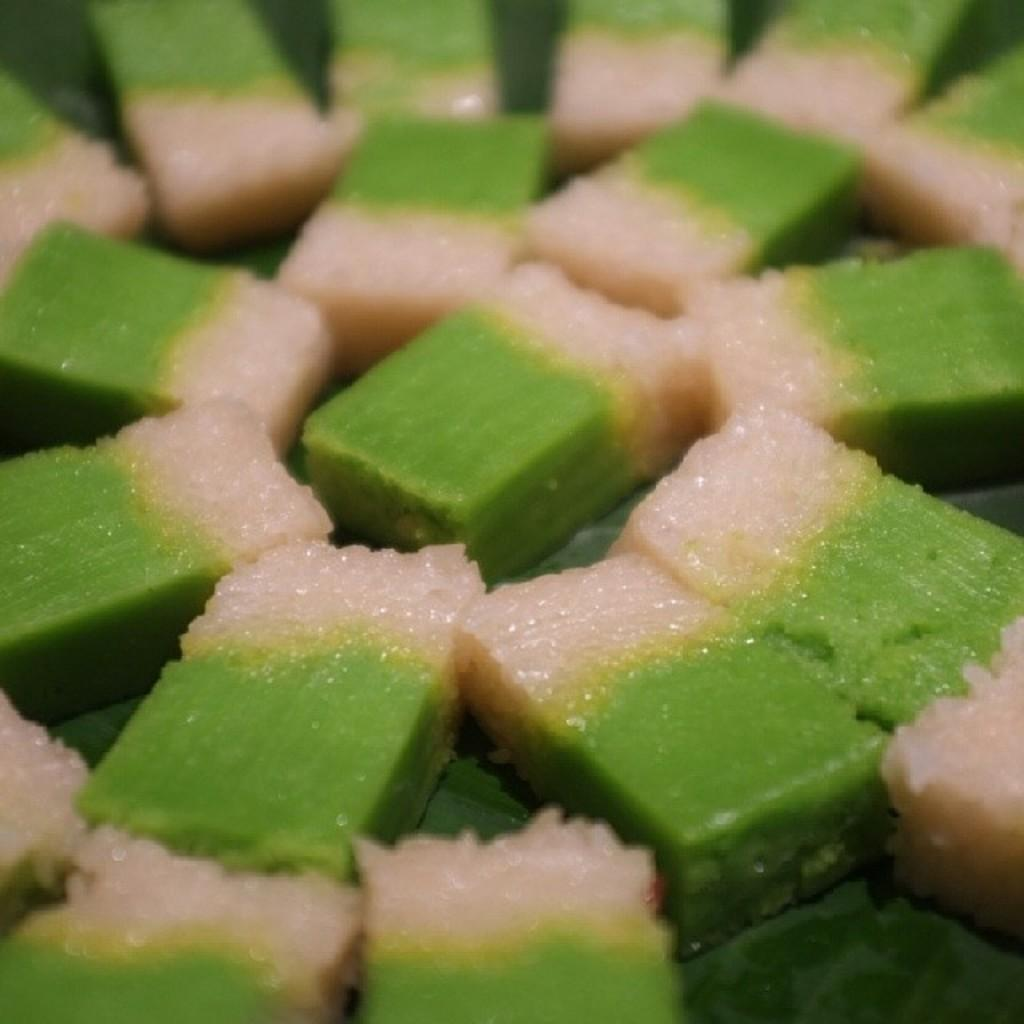What type of food item can be seen in the image? There is a food item in the image, but the specific type cannot be determined from the facts provided. What colors are present in the food item? The food item is in cream and green color. How is the food item arranged in the image? The food item is arranged in a circular shape. Where is the tin located in the image? There is no tin present in the image. Can you describe the snail's movement in the image? There is no snail present in the image, so its movement cannot be described. 